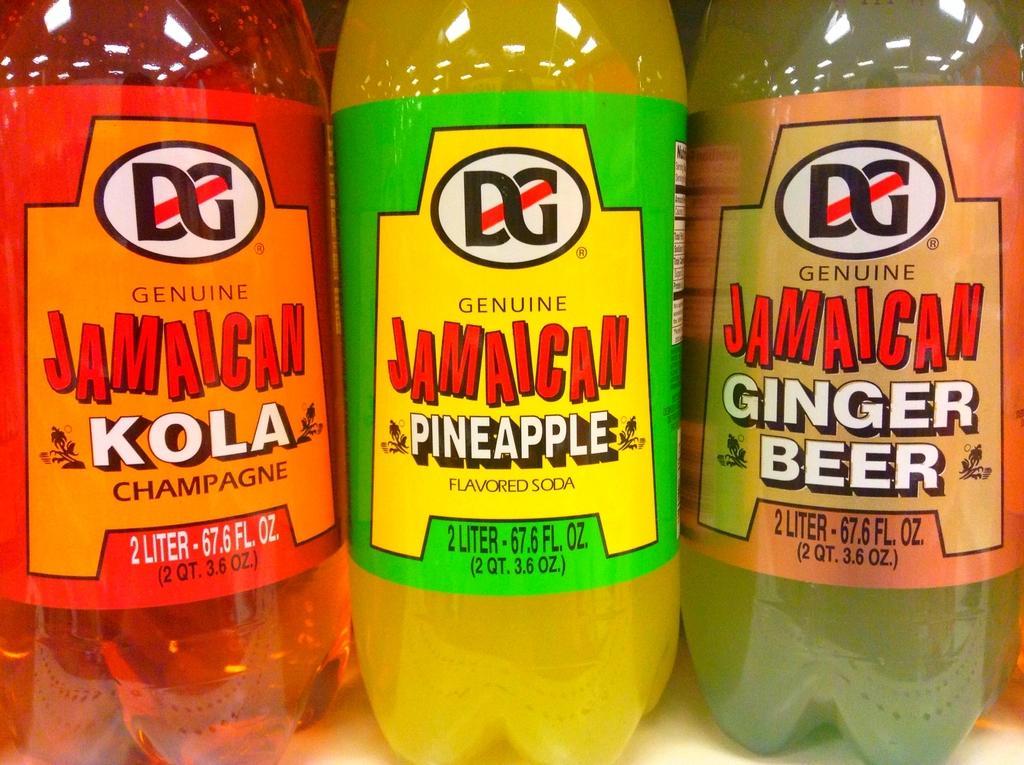Can you describe this image briefly? In this image i can see there are three plastic bottles. 